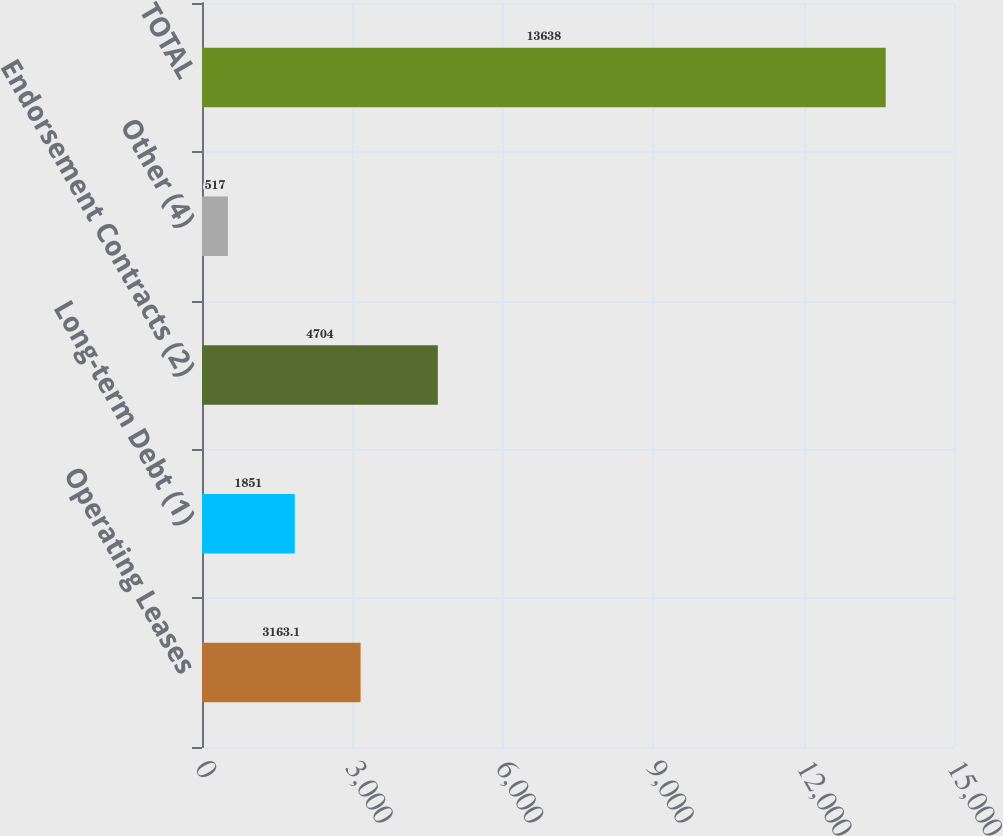Convert chart. <chart><loc_0><loc_0><loc_500><loc_500><bar_chart><fcel>Operating Leases<fcel>Long-term Debt (1)<fcel>Endorsement Contracts (2)<fcel>Other (4)<fcel>TOTAL<nl><fcel>3163.1<fcel>1851<fcel>4704<fcel>517<fcel>13638<nl></chart> 